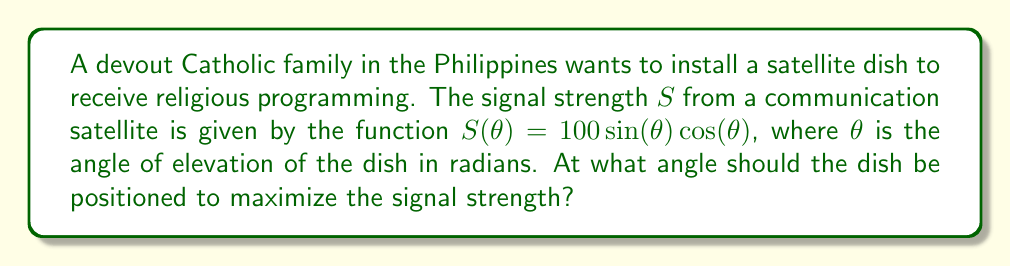Give your solution to this math problem. To find the optimal angle, we need to maximize the function $S(\theta) = 100\sin(\theta)\cos(\theta)$. Let's follow these steps:

1) First, we can simplify the function using the trigonometric identity $\sin(2\theta) = 2\sin(\theta)\cos(\theta)$:

   $S(\theta) = 100\sin(\theta)\cos(\theta) = 50\sin(2\theta)$

2) To find the maximum, we need to find where the derivative of $S(\theta)$ equals zero:

   $\frac{dS}{d\theta} = 50 \cdot 2\cos(2\theta) = 100\cos(2\theta)$

3) Set the derivative to zero and solve:

   $100\cos(2\theta) = 0$
   $\cos(2\theta) = 0$

4) The cosine function equals zero when its argument is $\frac{\pi}{2}$ or $\frac{3\pi}{2}$:

   $2\theta = \frac{\pi}{2}$ or $2\theta = \frac{3\pi}{2}$

5) Solving for $\theta$:

   $\theta = \frac{\pi}{4}$ or $\theta = \frac{3\pi}{4}$

6) To determine which of these is the maximum (rather than the minimum), we can check the second derivative:

   $\frac{d^2S}{d\theta^2} = -200\sin(2\theta)$

   At $\theta = \frac{\pi}{4}$, this is negative, indicating a maximum.

7) Convert radians to degrees:

   $\frac{\pi}{4}$ radians = $45°$

Therefore, the optimal angle for the satellite dish is 45° above the horizon.
Answer: $45°$ 